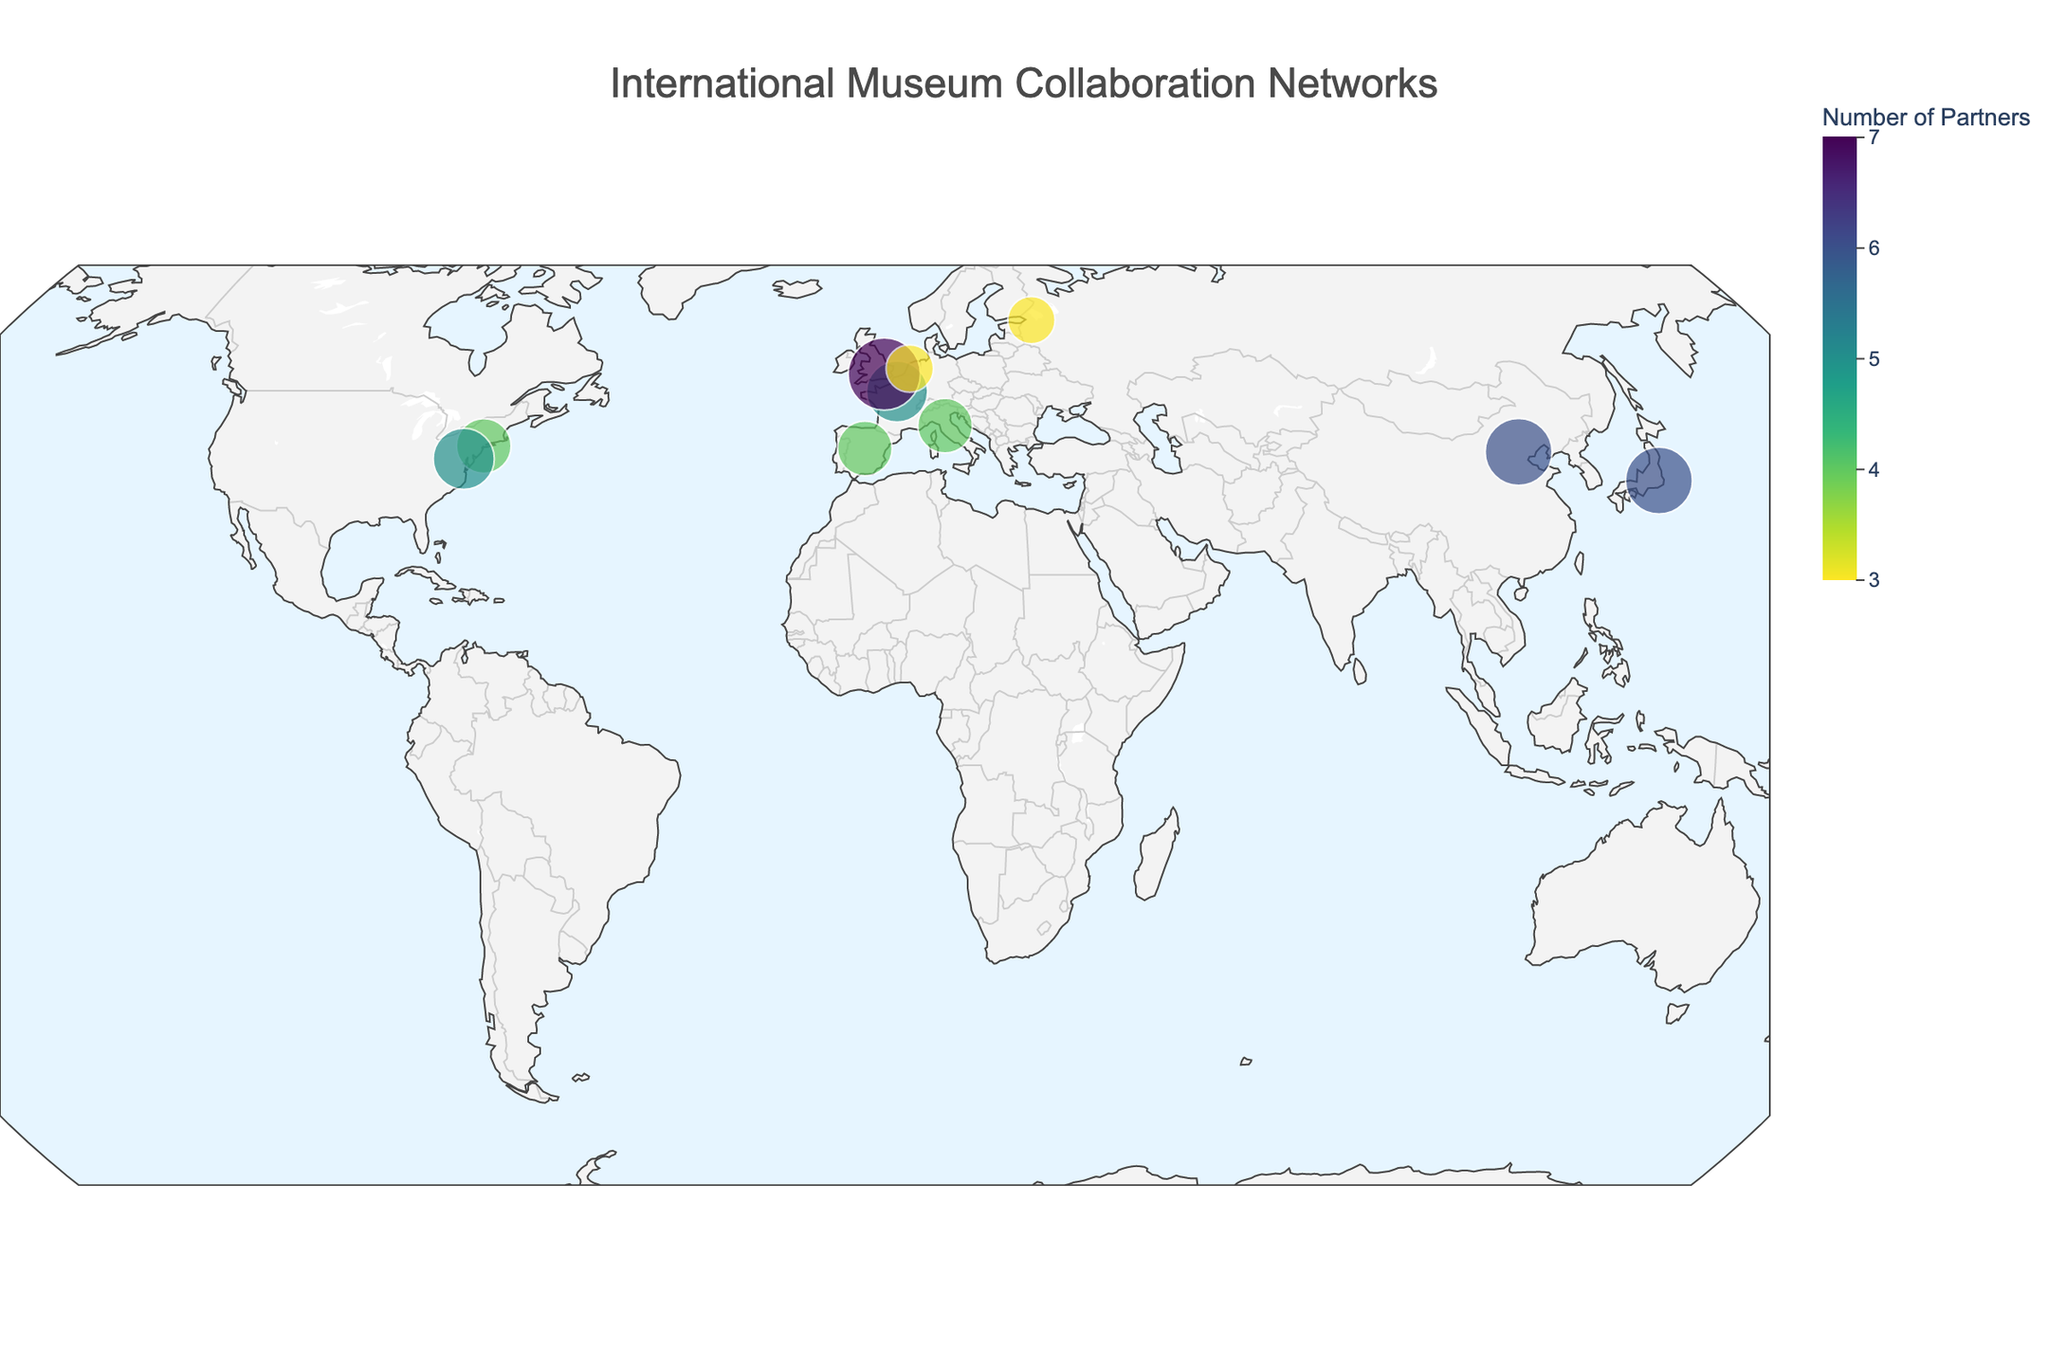How many museums are shown in the figure? Count each data point representing a museum in the figure. There are 10 museums listed in the data.
Answer: 10 Which museum has the most partners, and how many? Check the hover data or the color and size of the markers which are scaled based on the number of partners. The British Museum in London has the most partners with 7.
Answer: British Museum, 7 What is the predominant type of partnership depicted in the figure? Review the hover data for each museum to identify the types of partnerships. Since each museum has a different partnership type, there is no predominant type visible.
Answer: No predominant type Which two museums have the largest difference in the number of partners? Find the museums with the highest and lowest number of partners. The British Museum has 7 partners and both the State Hermitage Museum and Van Gogh Museum have 3 partners, making the largest difference 4.
Answer: British Museum and State Hermitage Museum/Van Gogh Museum What is the average number of partners per museum? Sum the number of partners for all museums and divide by the total number of museums. (5+7+4+3+6+4+3+5+4+6)/10 = 4.7
Answer: 4.7 Which museum in the USA has the most partners? Identify museums located in the USA and compare their number of partners. Both the Metropolitan Museum of Art and the National Gallery of Art have equal partners at 5.
Answer: Metropolitan Museum of Art/National Gallery of Art What geographic pattern do you notice from the distribution of the museums? Observe the geographic locations of the museums on the natural earth projection map. The museums are spread across major cities in Europe, Asia, and North America, indicating widespread international collaboration.
Answer: Spread across major cities Which museums are located in Asia, and how many partners do they have? Look for museums located in Asian countries like Japan and China. The National Museum of China in Beijing has 6 partners, and the Tokyo National Museum in Tokyo has 6 partners.
Answer: National Museum of China (6), Tokyo National Museum (6) How does the number of partners for museums in Europe compare with those in Asia? Sum the number of partners for European and Asian museums and compare them. European museums: Louvre (5), British Museum (7), Uffizi Gallery (4), Van Gogh Museum (3), Prado Museum (4) total 23. Asian museums: National Museum of China (6), Tokyo National Museum (6) total 12.
Answer: Europe has more partners (23) than Asia (12) 